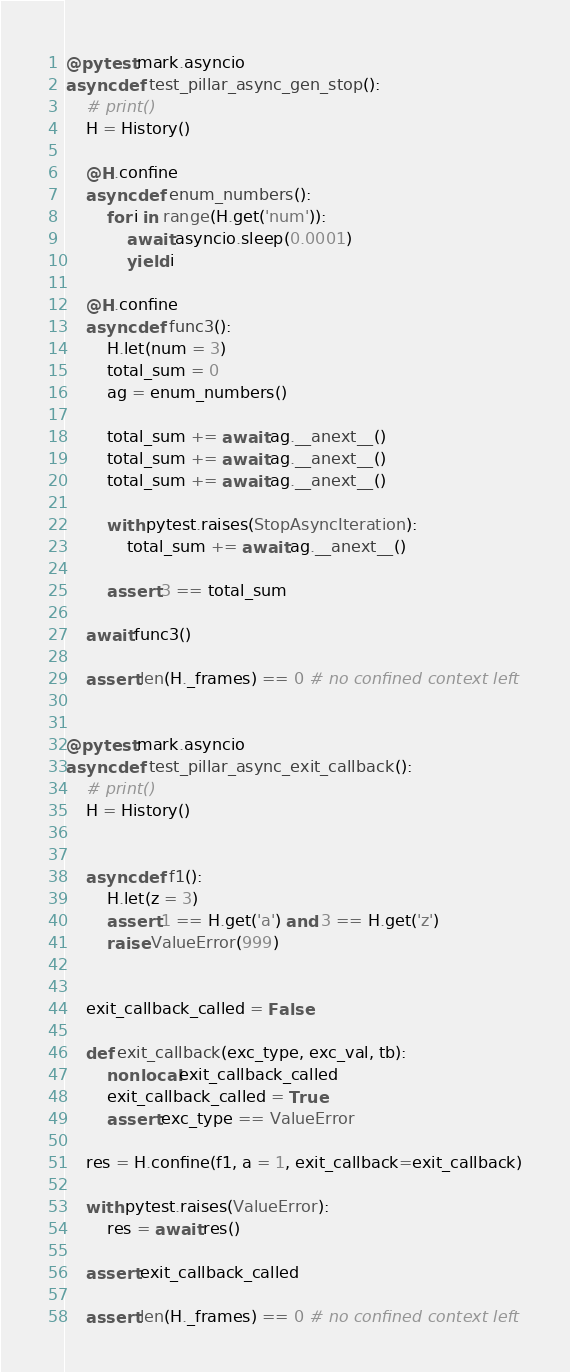Convert code to text. <code><loc_0><loc_0><loc_500><loc_500><_Python_>
@pytest.mark.asyncio
async def test_pillar_async_gen_stop():
    # print()
    H = History()

    @H.confine
    async def enum_numbers():
        for i in range(H.get('num')):
            await asyncio.sleep(0.0001)
            yield i

    @H.confine
    async def func3():
        H.let(num = 3)
        total_sum = 0
        ag = enum_numbers()

        total_sum += await ag.__anext__()
        total_sum += await ag.__anext__()
        total_sum += await ag.__anext__()

        with pytest.raises(StopAsyncIteration):
            total_sum += await ag.__anext__()

        assert 3 == total_sum

    await func3()

    assert len(H._frames) == 0 # no confined context left


@pytest.mark.asyncio
async def test_pillar_async_exit_callback():
    # print()
    H = History()


    async def f1():
        H.let(z = 3)
        assert 1 == H.get('a') and 3 == H.get('z')
        raise ValueError(999)


    exit_callback_called = False

    def exit_callback(exc_type, exc_val, tb):
        nonlocal exit_callback_called
        exit_callback_called = True
        assert exc_type == ValueError

    res = H.confine(f1, a = 1, exit_callback=exit_callback)

    with pytest.raises(ValueError):
        res = await res()

    assert exit_callback_called

    assert len(H._frames) == 0 # no confined context left
</code> 